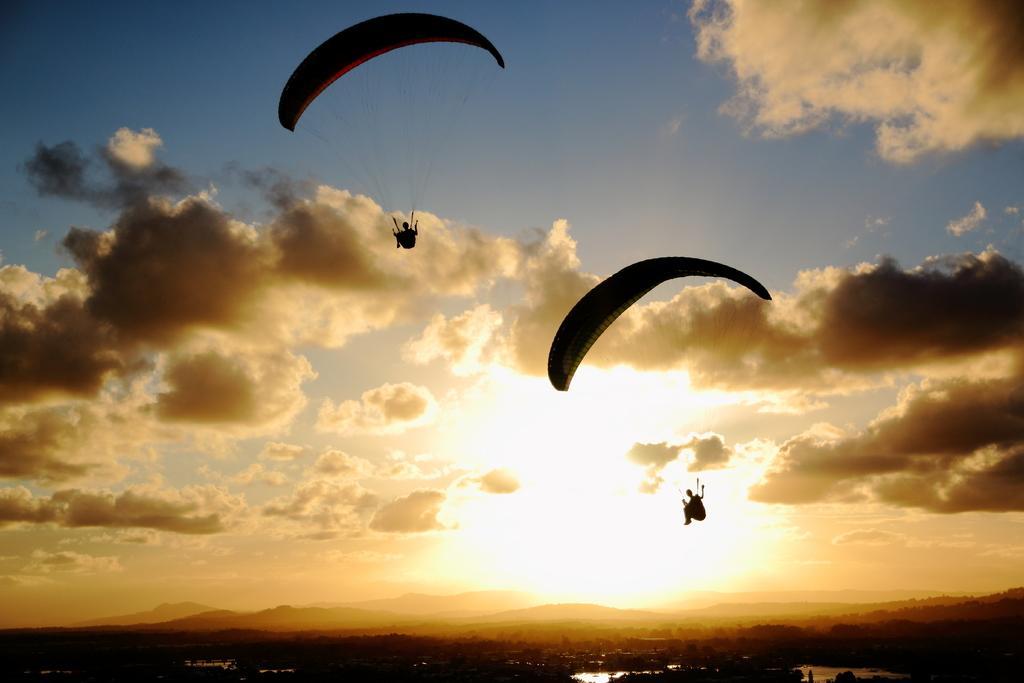Please provide a concise description of this image. In this picture i can see two people are doing parachuting. In the background i can see sky and mountains. 